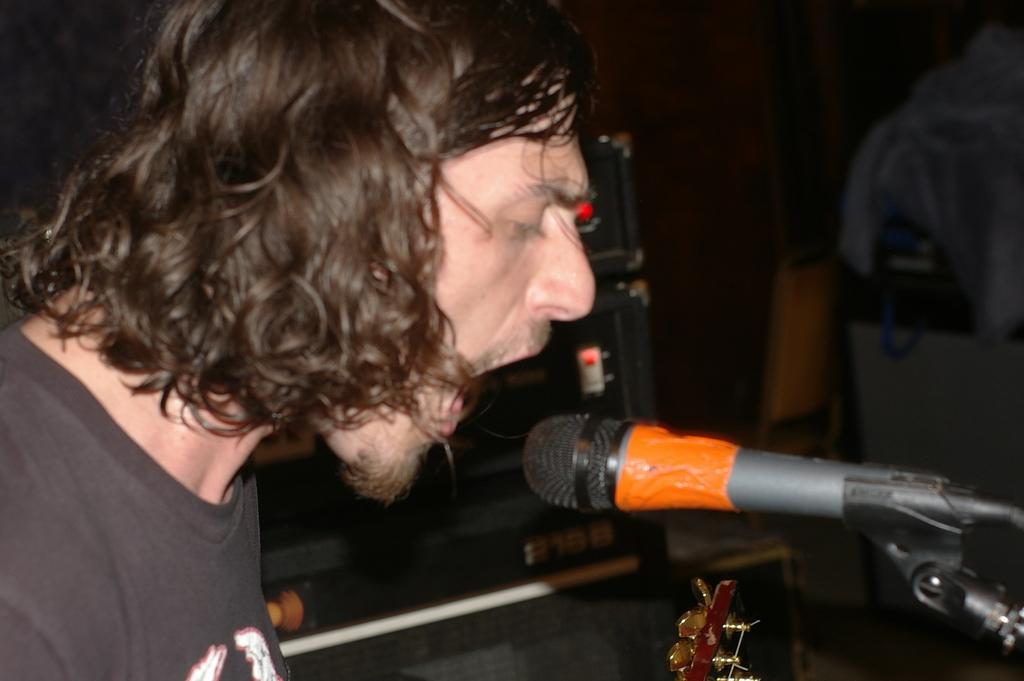What is the man in the image doing? The man is singing in the image. What object is the man using while singing? The man is in front of a microphone. Can you describe the background of the image? The background of the image is blurred. What musical instrument is visible in the image? There is a guitar visible at the bottom of the image. What is the man wearing? The man is wearing a black T-shirt. How many cats are visible in the image? There are no cats present in the image. What is the size of the man in the image? The size of the man cannot be determined from the image alone, as it only provides a 2D representation. 